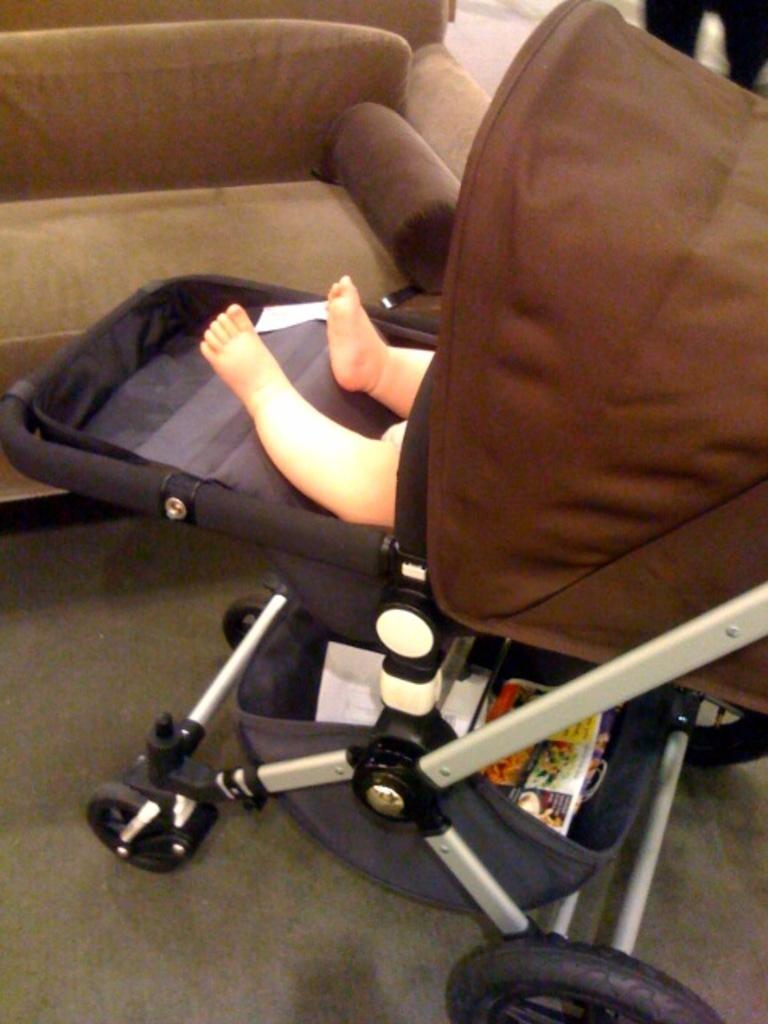What is the main subject of the image? There is a baby in a pram in the image. What part of the baby can be seen in the image? The baby's legs are visible. What type of furniture is in the background of the image? There is a sofa in the background of the image. What is located at the bottom of the image? Papers are present at the bottom of the image. What allows the pram to be moved around? There are wheels visible in the image. What type of shoe is the baby wearing in the image? The image does not show the baby wearing any shoes, as the baby is in a pram. Can you tell me how many nuts are present in the image? There are no nuts visible in the image. 